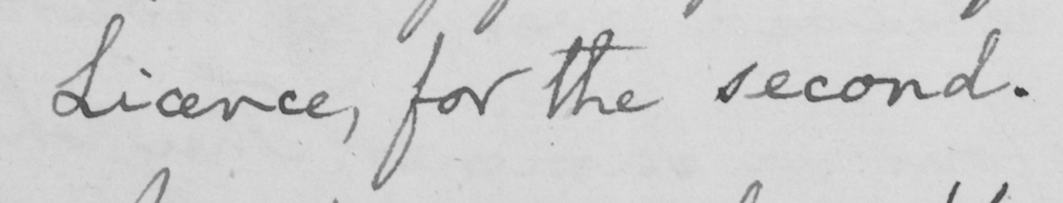Transcribe the text shown in this historical manuscript line. Licence , for the second . 